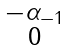<formula> <loc_0><loc_0><loc_500><loc_500>\begin{smallmatrix} - \alpha _ { - 1 } \\ 0 \end{smallmatrix}</formula> 